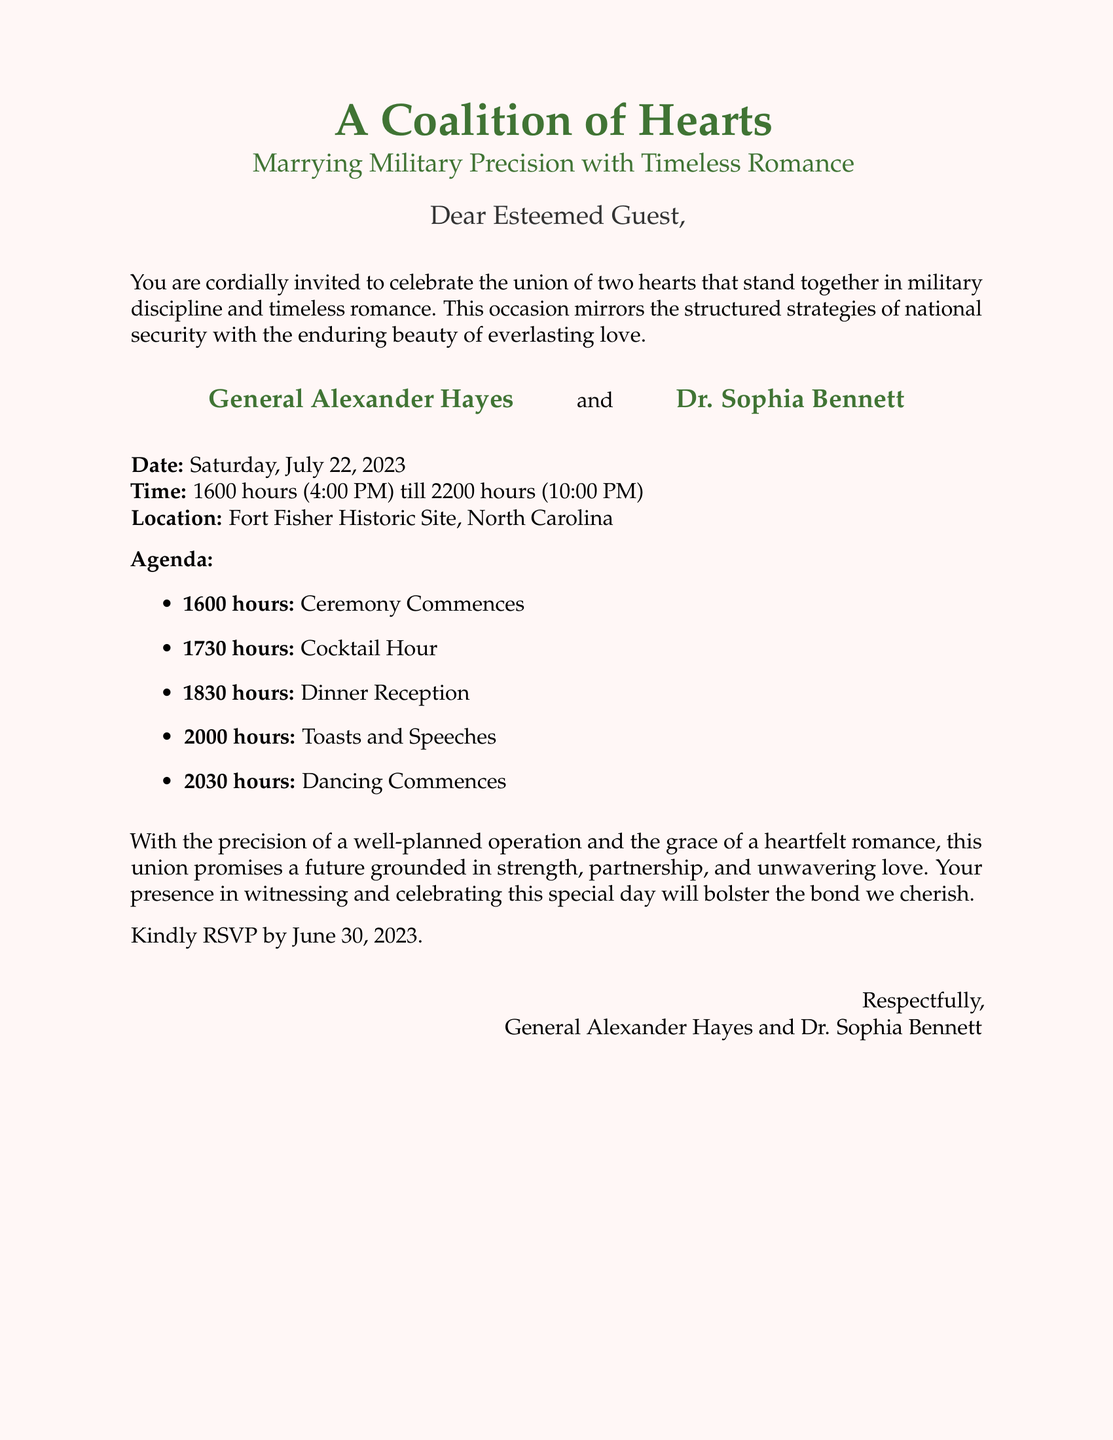What is the title of the event? The title of the event is prominently displayed at the top of the invitation.
Answer: A Coalition of Hearts Who are the individuals getting married? The invitation lists the names of the people involved in the union.
Answer: General Alexander Hayes and Dr. Sophia Bennett What is the date of the wedding? The specific day of the wedding is clearly stated in the invitation.
Answer: Saturday, July 22, 2023 What time does the ceremony commence? The invitation indicates the start time of the ceremony.
Answer: 1600 hours (4:00 PM) What is the location of the wedding? The invitation provides the venue for the event.
Answer: Fort Fisher Historic Site, North Carolina What is the RSVP deadline? The invitation specifies when guests should respond by.
Answer: June 30, 2023 What is included in the agenda at 2000 hours? The agenda outlines the events scheduled for a certain time during the celebration.
Answer: Toasts and Speeches What theme does the wedding emphasize? The invitation reflects the overall theme of the event in its title.
Answer: Military Precision with Timeless Romance What type of invitation is this document? The document is categorized based on its purpose and audience.
Answer: Wedding invitation 